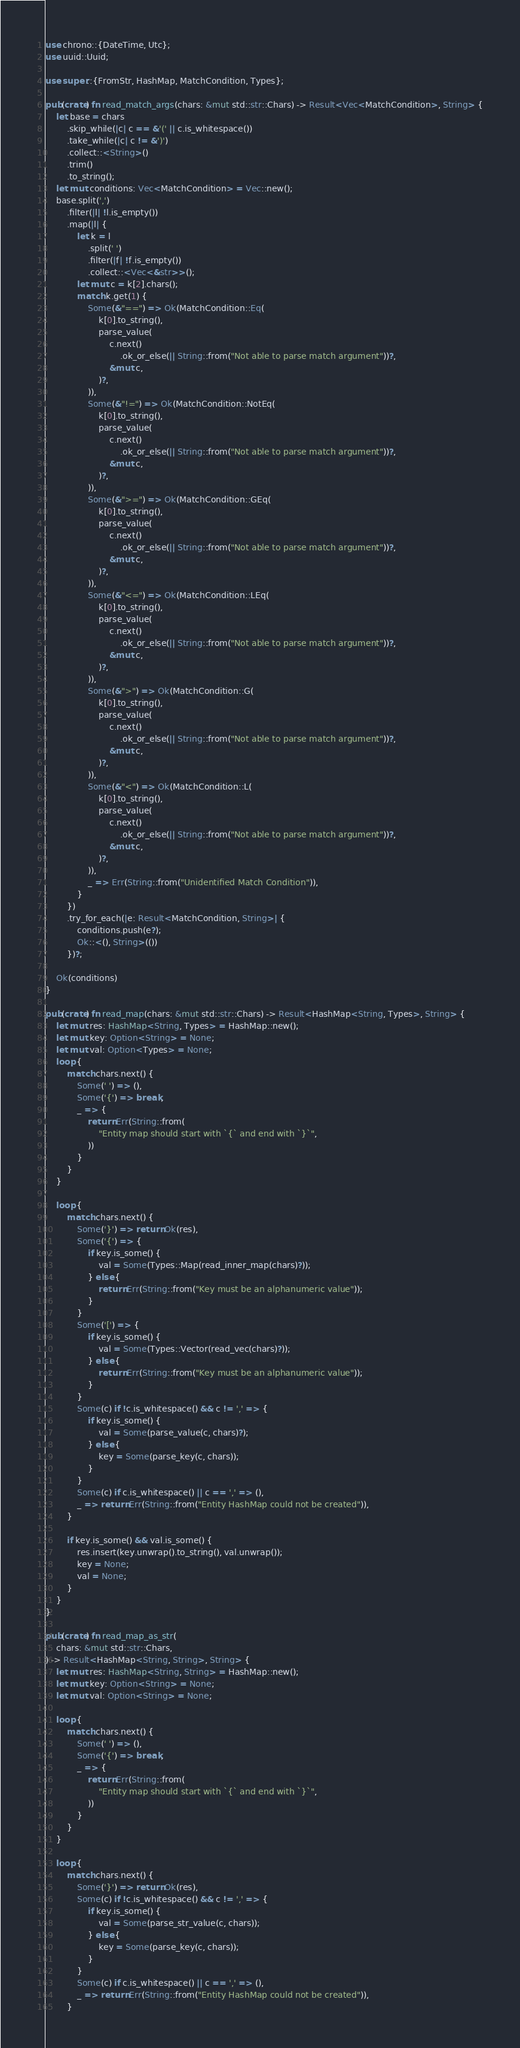Convert code to text. <code><loc_0><loc_0><loc_500><loc_500><_Rust_>use chrono::{DateTime, Utc};
use uuid::Uuid;

use super::{FromStr, HashMap, MatchCondition, Types};

pub(crate) fn read_match_args(chars: &mut std::str::Chars) -> Result<Vec<MatchCondition>, String> {
    let base = chars
        .skip_while(|c| c == &'(' || c.is_whitespace())
        .take_while(|c| c != &')')
        .collect::<String>()
        .trim()
        .to_string();
    let mut conditions: Vec<MatchCondition> = Vec::new();
    base.split(',')
        .filter(|l| !l.is_empty())
        .map(|l| {
            let k = l
                .split(' ')
                .filter(|f| !f.is_empty())
                .collect::<Vec<&str>>();
            let mut c = k[2].chars();
            match k.get(1) {
                Some(&"==") => Ok(MatchCondition::Eq(
                    k[0].to_string(),
                    parse_value(
                        c.next()
                            .ok_or_else(|| String::from("Not able to parse match argument"))?,
                        &mut c,
                    )?,
                )),
                Some(&"!=") => Ok(MatchCondition::NotEq(
                    k[0].to_string(),
                    parse_value(
                        c.next()
                            .ok_or_else(|| String::from("Not able to parse match argument"))?,
                        &mut c,
                    )?,
                )),
                Some(&">=") => Ok(MatchCondition::GEq(
                    k[0].to_string(),
                    parse_value(
                        c.next()
                            .ok_or_else(|| String::from("Not able to parse match argument"))?,
                        &mut c,
                    )?,
                )),
                Some(&"<=") => Ok(MatchCondition::LEq(
                    k[0].to_string(),
                    parse_value(
                        c.next()
                            .ok_or_else(|| String::from("Not able to parse match argument"))?,
                        &mut c,
                    )?,
                )),
                Some(&">") => Ok(MatchCondition::G(
                    k[0].to_string(),
                    parse_value(
                        c.next()
                            .ok_or_else(|| String::from("Not able to parse match argument"))?,
                        &mut c,
                    )?,
                )),
                Some(&"<") => Ok(MatchCondition::L(
                    k[0].to_string(),
                    parse_value(
                        c.next()
                            .ok_or_else(|| String::from("Not able to parse match argument"))?,
                        &mut c,
                    )?,
                )),
                _ => Err(String::from("Unidentified Match Condition")),
            }
        })
        .try_for_each(|e: Result<MatchCondition, String>| {
            conditions.push(e?);
            Ok::<(), String>(())
        })?;

    Ok(conditions)
}

pub(crate) fn read_map(chars: &mut std::str::Chars) -> Result<HashMap<String, Types>, String> {
    let mut res: HashMap<String, Types> = HashMap::new();
    let mut key: Option<String> = None;
    let mut val: Option<Types> = None;
    loop {
        match chars.next() {
            Some(' ') => (),
            Some('{') => break,
            _ => {
                return Err(String::from(
                    "Entity map should start with `{` and end with `}`",
                ))
            }
        }
    }

    loop {
        match chars.next() {
            Some('}') => return Ok(res),
            Some('{') => {
                if key.is_some() {
                    val = Some(Types::Map(read_inner_map(chars)?));
                } else {
                    return Err(String::from("Key must be an alphanumeric value"));
                }
            }
            Some('[') => {
                if key.is_some() {
                    val = Some(Types::Vector(read_vec(chars)?));
                } else {
                    return Err(String::from("Key must be an alphanumeric value"));
                }
            }
            Some(c) if !c.is_whitespace() && c != ',' => {
                if key.is_some() {
                    val = Some(parse_value(c, chars)?);
                } else {
                    key = Some(parse_key(c, chars));
                }
            }
            Some(c) if c.is_whitespace() || c == ',' => (),
            _ => return Err(String::from("Entity HashMap could not be created")),
        }

        if key.is_some() && val.is_some() {
            res.insert(key.unwrap().to_string(), val.unwrap());
            key = None;
            val = None;
        }
    }
}

pub(crate) fn read_map_as_str(
    chars: &mut std::str::Chars,
) -> Result<HashMap<String, String>, String> {
    let mut res: HashMap<String, String> = HashMap::new();
    let mut key: Option<String> = None;
    let mut val: Option<String> = None;

    loop {
        match chars.next() {
            Some(' ') => (),
            Some('{') => break,
            _ => {
                return Err(String::from(
                    "Entity map should start with `{` and end with `}`",
                ))
            }
        }
    }

    loop {
        match chars.next() {
            Some('}') => return Ok(res),
            Some(c) if !c.is_whitespace() && c != ',' => {
                if key.is_some() {
                    val = Some(parse_str_value(c, chars));
                } else {
                    key = Some(parse_key(c, chars));
                }
            }
            Some(c) if c.is_whitespace() || c == ',' => (),
            _ => return Err(String::from("Entity HashMap could not be created")),
        }
</code> 